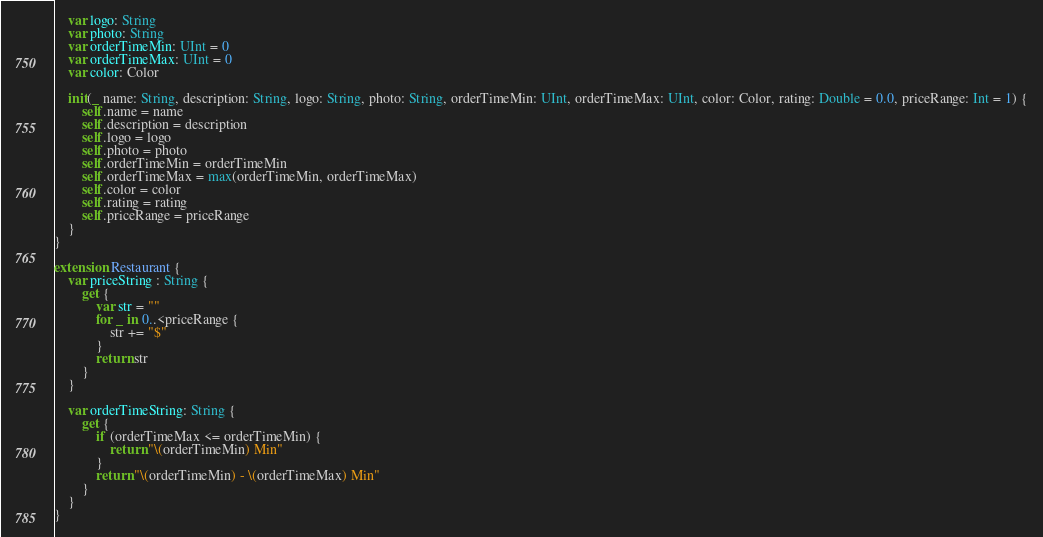<code> <loc_0><loc_0><loc_500><loc_500><_Swift_>    var logo: String
    var photo: String
    var orderTimeMin: UInt = 0
    var orderTimeMax: UInt = 0
    var color: Color
    
    init(_ name: String, description: String, logo: String, photo: String, orderTimeMin: UInt, orderTimeMax: UInt, color: Color, rating: Double = 0.0, priceRange: Int = 1) {
        self.name = name
        self.description = description
        self.logo = logo
        self.photo = photo
        self.orderTimeMin = orderTimeMin
        self.orderTimeMax = max(orderTimeMin, orderTimeMax)
        self.color = color
        self.rating = rating
        self.priceRange = priceRange
    }
}

extension Restaurant {
    var priceString : String {
        get {
            var str = ""
            for _ in 0..<priceRange {
                str += "$"
            }
            return str
        }
    }
    
    var orderTimeString: String {
        get {
            if (orderTimeMax <= orderTimeMin) {
                return "\(orderTimeMin) Min"
            }
            return "\(orderTimeMin) - \(orderTimeMax) Min"
        }
    }
}
</code> 